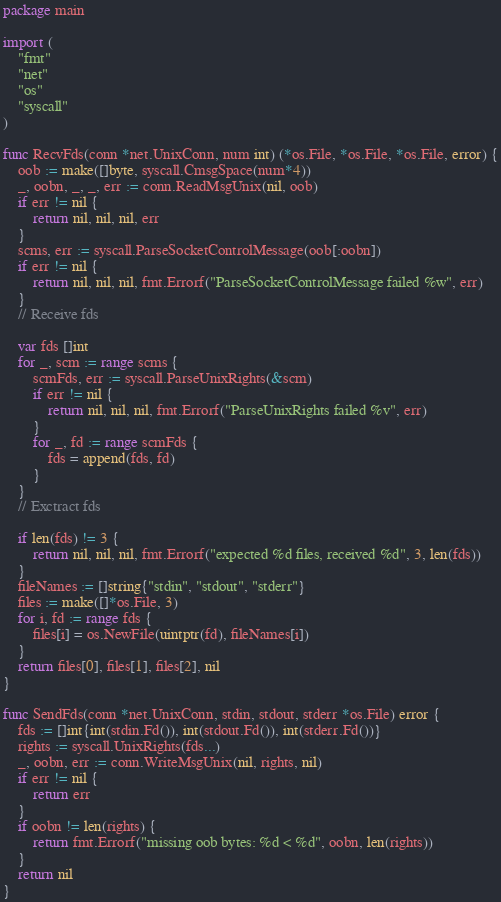Convert code to text. <code><loc_0><loc_0><loc_500><loc_500><_Go_>package main

import (
	"fmt"
	"net"
	"os"
	"syscall"
)

func RecvFds(conn *net.UnixConn, num int) (*os.File, *os.File, *os.File, error) {
	oob := make([]byte, syscall.CmsgSpace(num*4))
	_, oobn, _, _, err := conn.ReadMsgUnix(nil, oob)
	if err != nil {
		return nil, nil, nil, err
	}
	scms, err := syscall.ParseSocketControlMessage(oob[:oobn])
	if err != nil {
		return nil, nil, nil, fmt.Errorf("ParseSocketControlMessage failed %w", err)
	}
	// Receive fds

	var fds []int
	for _, scm := range scms {
		scmFds, err := syscall.ParseUnixRights(&scm)
		if err != nil {
			return nil, nil, nil, fmt.Errorf("ParseUnixRights failed %v", err)
		}
		for _, fd := range scmFds {
			fds = append(fds, fd)
		}
	}
	// Exctract fds

	if len(fds) != 3 {
		return nil, nil, nil, fmt.Errorf("expected %d files, received %d", 3, len(fds))
	}
	fileNames := []string{"stdin", "stdout", "stderr"}
	files := make([]*os.File, 3)
	for i, fd := range fds {
		files[i] = os.NewFile(uintptr(fd), fileNames[i])
	}
	return files[0], files[1], files[2], nil
}

func SendFds(conn *net.UnixConn, stdin, stdout, stderr *os.File) error {
	fds := []int{int(stdin.Fd()), int(stdout.Fd()), int(stderr.Fd())}
	rights := syscall.UnixRights(fds...)
	_, oobn, err := conn.WriteMsgUnix(nil, rights, nil)
	if err != nil {
		return err
	}
	if oobn != len(rights) {
		return fmt.Errorf("missing oob bytes: %d < %d", oobn, len(rights))
	}
	return nil
}
</code> 